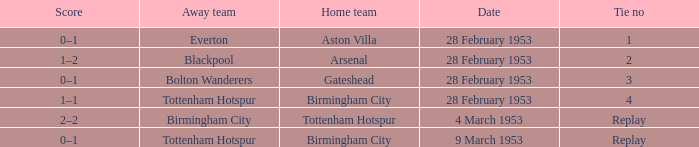Which Score has a Home team of aston villa? 0–1. 